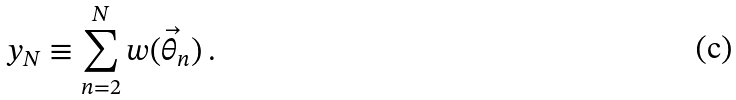<formula> <loc_0><loc_0><loc_500><loc_500>y _ { N } \equiv \sum _ { n = 2 } ^ { N } w ( \vec { \theta } _ { n } ) \, .</formula> 